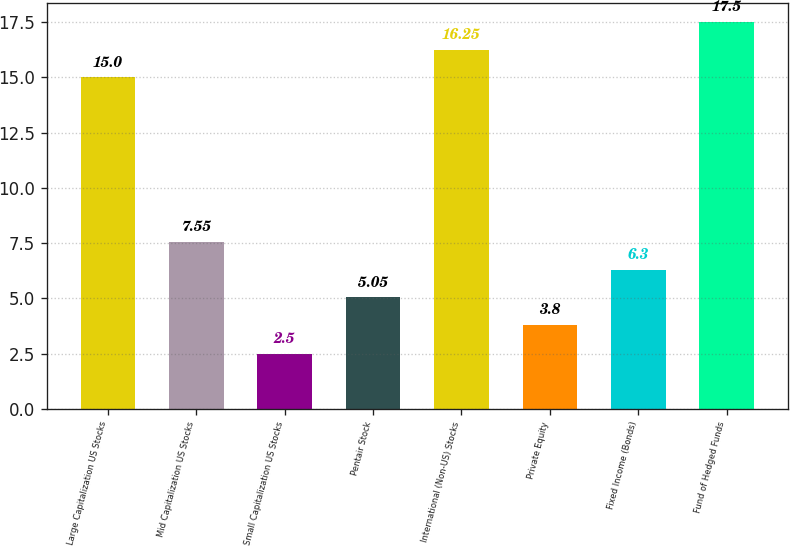Convert chart. <chart><loc_0><loc_0><loc_500><loc_500><bar_chart><fcel>Large Capitalization US Stocks<fcel>Mid Capitalization US Stocks<fcel>Small Capitalization US Stocks<fcel>Pentair Stock<fcel>International (Non-US) Stocks<fcel>Private Equity<fcel>Fixed Income (Bonds)<fcel>Fund of Hedged Funds<nl><fcel>15<fcel>7.55<fcel>2.5<fcel>5.05<fcel>16.25<fcel>3.8<fcel>6.3<fcel>17.5<nl></chart> 